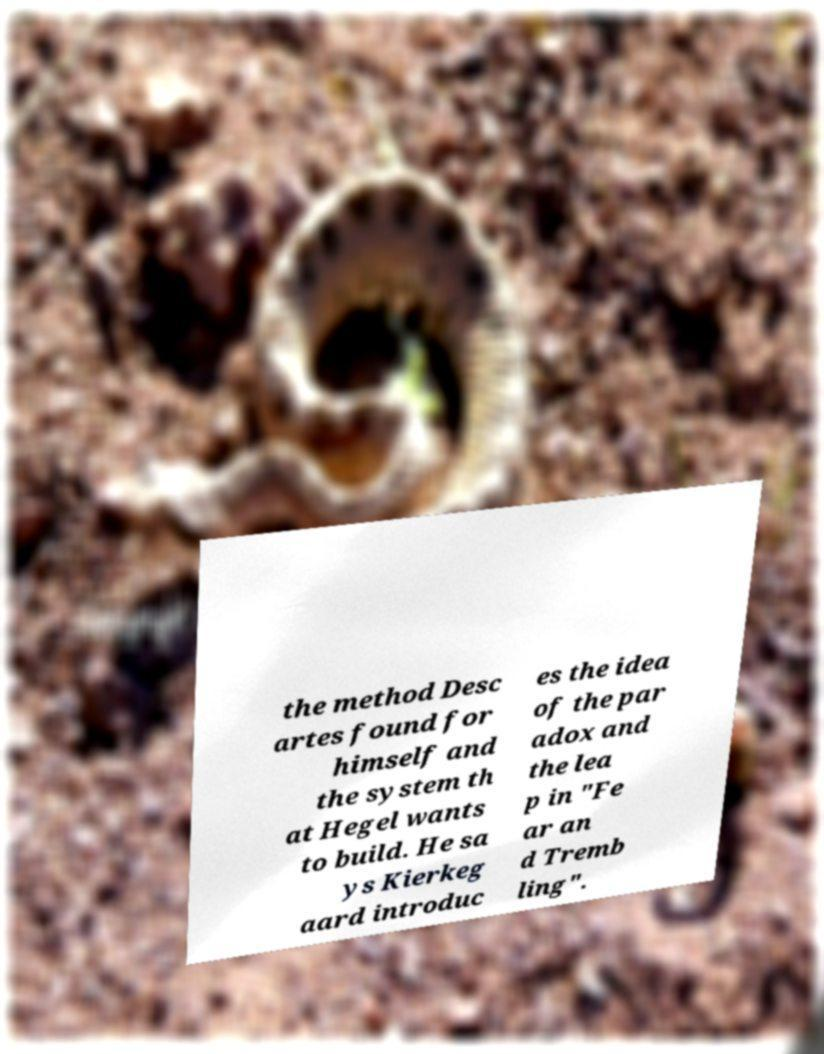Could you assist in decoding the text presented in this image and type it out clearly? the method Desc artes found for himself and the system th at Hegel wants to build. He sa ys Kierkeg aard introduc es the idea of the par adox and the lea p in "Fe ar an d Tremb ling". 